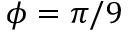Convert formula to latex. <formula><loc_0><loc_0><loc_500><loc_500>\phi = \pi / 9</formula> 